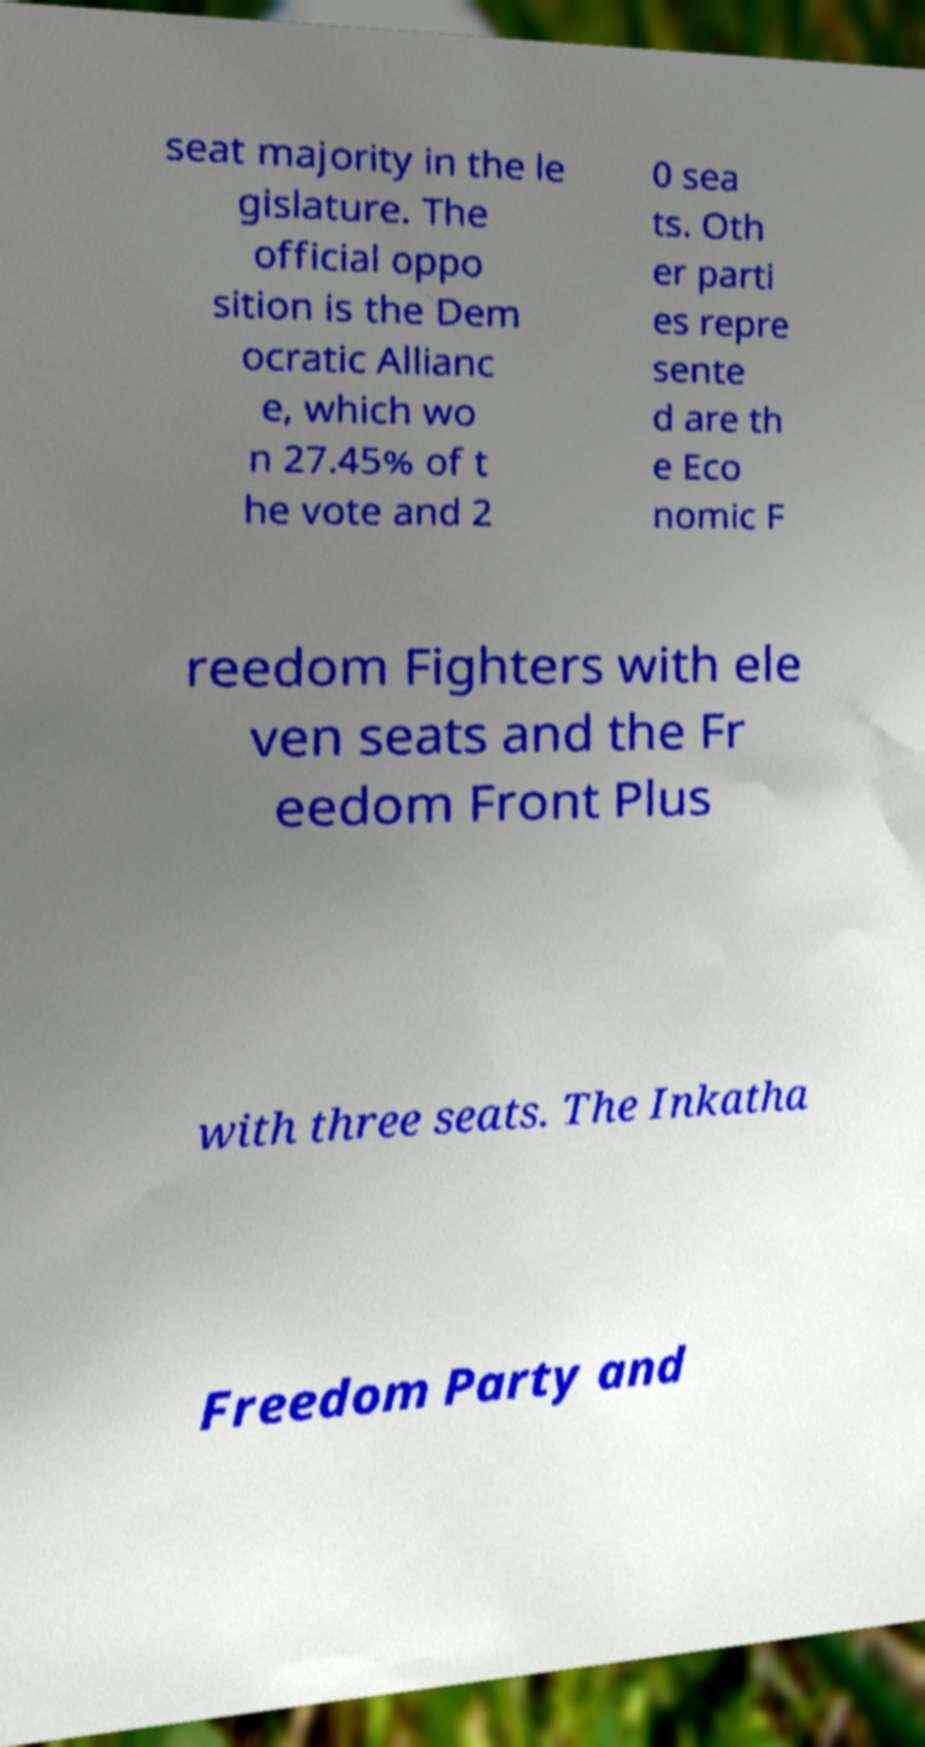There's text embedded in this image that I need extracted. Can you transcribe it verbatim? seat majority in the le gislature. The official oppo sition is the Dem ocratic Allianc e, which wo n 27.45% of t he vote and 2 0 sea ts. Oth er parti es repre sente d are th e Eco nomic F reedom Fighters with ele ven seats and the Fr eedom Front Plus with three seats. The Inkatha Freedom Party and 